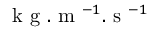Convert formula to latex. <formula><loc_0><loc_0><loc_500><loc_500>k g . m ^ { - 1 } . s ^ { - 1 }</formula> 